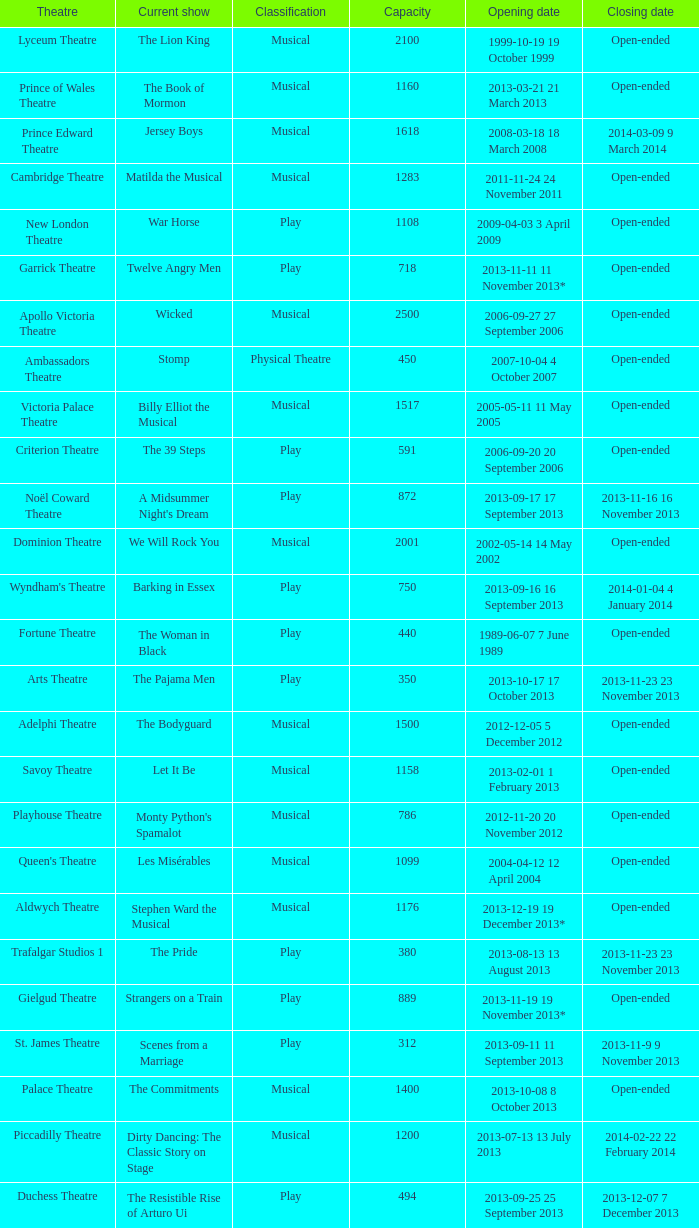What opening date has a capacity of 100? 2013-11-01 1 November 2013. 